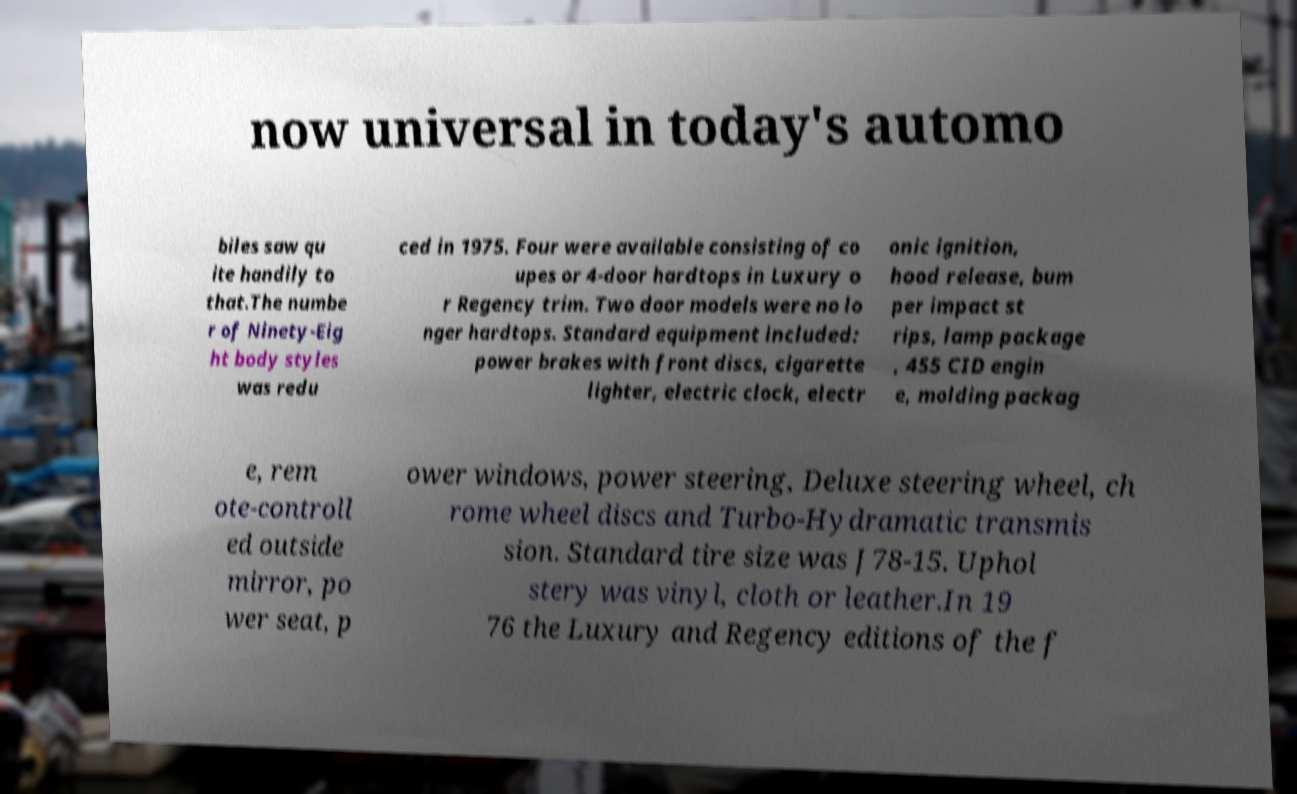Could you assist in decoding the text presented in this image and type it out clearly? now universal in today's automo biles saw qu ite handily to that.The numbe r of Ninety-Eig ht body styles was redu ced in 1975. Four were available consisting of co upes or 4-door hardtops in Luxury o r Regency trim. Two door models were no lo nger hardtops. Standard equipment included: power brakes with front discs, cigarette lighter, electric clock, electr onic ignition, hood release, bum per impact st rips, lamp package , 455 CID engin e, molding packag e, rem ote-controll ed outside mirror, po wer seat, p ower windows, power steering, Deluxe steering wheel, ch rome wheel discs and Turbo-Hydramatic transmis sion. Standard tire size was J78-15. Uphol stery was vinyl, cloth or leather.In 19 76 the Luxury and Regency editions of the f 